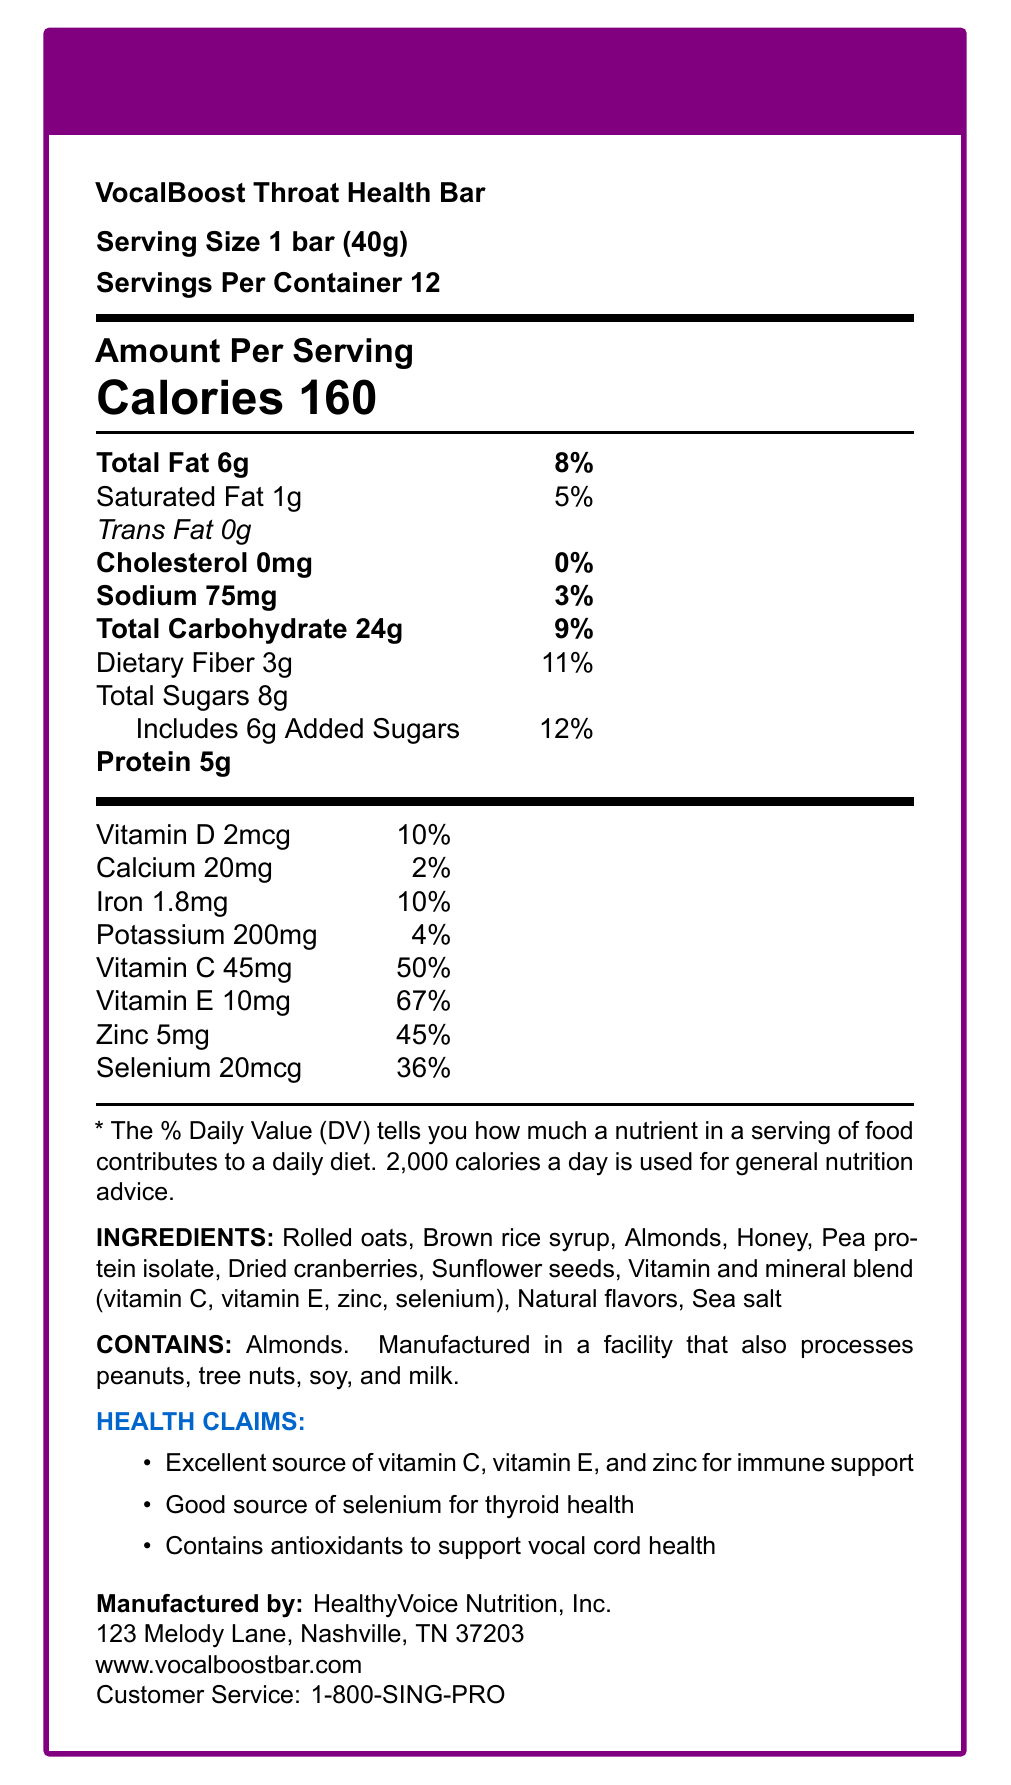What is the serving size for the VocalBoost Throat Health Bar? The document lists the serving size as "1 bar (40g)" at the beginning.
Answer: 1 bar (40g) How many calories are in one serving of the VocalBoost Throat Health Bar? The large text under "Amount Per Serving" clearly states "Calories 160."
Answer: 160 calories How much protein is in a single bar of VocalBoost? The nutritional facts table lists "Protein 5g" under "Amount Per Serving."
Answer: 5g Which vitamins are included in the "vitamin and mineral blend"? These ingredients are explicitly listed in the "Ingredients" section as part of the "vitamin and mineral blend."
Answer: Vitamin C, Vitamin E, Zinc, Selenium Which company manufactures the VocalBoost Throat Health Bar? The "Manufactured by" section states that the product is made by "HealthyVoice Nutrition, Inc."
Answer: HealthyVoice Nutrition, Inc. What percentage of the daily value for Vitamin E does one serving provide? The table under "Amount Per Serving" lists "Vitamin E 10mg" with a daily value of "67%."
Answer: 67% What are some of the health claims made for the VocalBoost Throat Health Bar? The "Health Claims" section lists these specific claims.
Answer: Excellent source of vitamin C, vitamin E, and zinc for immune support; Good source of selenium for thyroid health; Contains antioxidants to support vocal cord health Multiple-choice: Which of the following is true about the iron content in the VocalBoost Throat Health Bar?
A. 1.8mg, 5% DV
B. 2mg, 10% DV
C. 1.8mg, 10% DV
D. 2mg, 5% DV The "Amount Per Serving" table lists "Iron 1.8mg" with a daily value of "10%."
Answer: C Multiple-choice: What allergen information is provided for the VocalBoost Throat Health Bar?
A. Contains peanuts.
B. Contains soy.
C. Contains almonds.
D. Contains milk. The "Allergen Info" section states that it "Contains almonds."
Answer: C Yes/No: Is the VocalBoost Throat Health Bar manufactured in a facility that processes soy? The "Allergen Info" section indicates that the bar is "Manufactured in a facility that also processes peanuts, tree nuts, soy, and milk."
Answer: Yes Summary: Describe the main information presented in the VocalBoost Throat Health Bar Nutrition Facts Label. This summary captures the overall content of the document, including nutritional details, ingredients, health claims, and manufacturer information.
Answer: The VocalBoost Throat Health Bar Nutrition Facts Label provides detailed nutritional information for a 40g serving size. It has 160 calories per bar with specific amounts for various nutrients such as total fat, carbohydrates, dietary fiber, sugars, protein, vitamins, and minerals along with their respective daily values. It also includes a list of ingredients, allergen info, and several health claims targeting immune support, thyroid health, and vocal cord support. Additionally, the label provides the manufacturer's details, including the company name, address, website, and customer service number. What is the exact quantity of added sugars in one serving of the VocalBoost Throat Health Bar? The document specifies that the total sugars include "6g Added Sugars."
Answer: 6g Is there any information on the presence of natural flavors in the VocalBoost Throat Health Bar? The ingredients list includes "Natural flavors."
Answer: Yes What is the daily value percentage for calcium in the VocalBoost Throat Health Bar? The "Amount Per Serving" table lists "Calcium 20mg" with a daily value of "2%."
Answer: 2% What is the complete address of the manufacturer of the VocalBoost Throat Health Bar? This information is provided in the "Manufactured by" section.
Answer: 123 Melody Lane, Nashville, TN 37203 Does the document specify whether the bar contains any trans fats? The document states "Trans Fat 0g."
Answer: No How much sodium does one serving of the VocalBoost Throat Health Bar contain, and what is its daily value percentage? The "Amount Per Serving" table lists "Sodium 75mg" with a daily value of "3%."
Answer: 75mg, 3% Unanswerable: What is the source of the antioxidants in the VocalBoost Throat Health Bar? The document mentions the presence of antioxidants but does not specify their source in detail.
Answer: Not enough information 